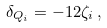Convert formula to latex. <formula><loc_0><loc_0><loc_500><loc_500>\delta _ { Q _ { i } } = - 1 2 \zeta _ { i } \, ,</formula> 